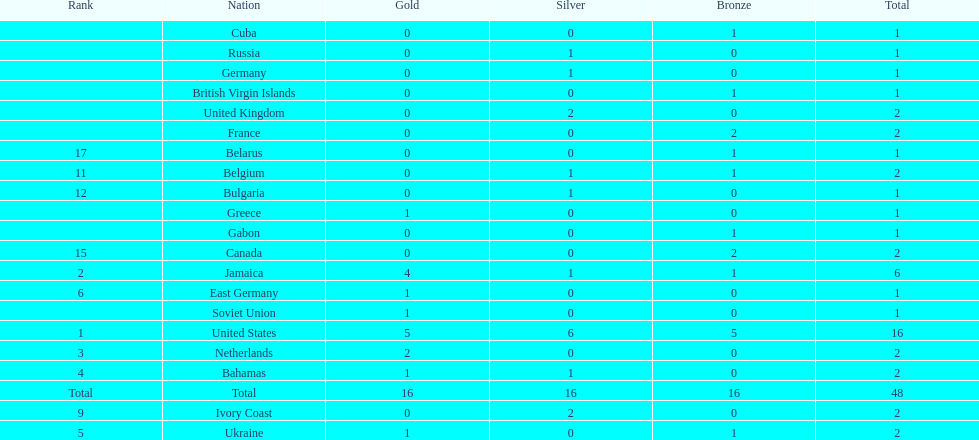Which nations took home at least one gold medal in the 60 metres competition? United States, Jamaica, Netherlands, Bahamas, Ukraine, East Germany, Greece, Soviet Union. Of these nations, which one won the most gold medals? United States. 